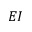Convert formula to latex. <formula><loc_0><loc_0><loc_500><loc_500>E I</formula> 